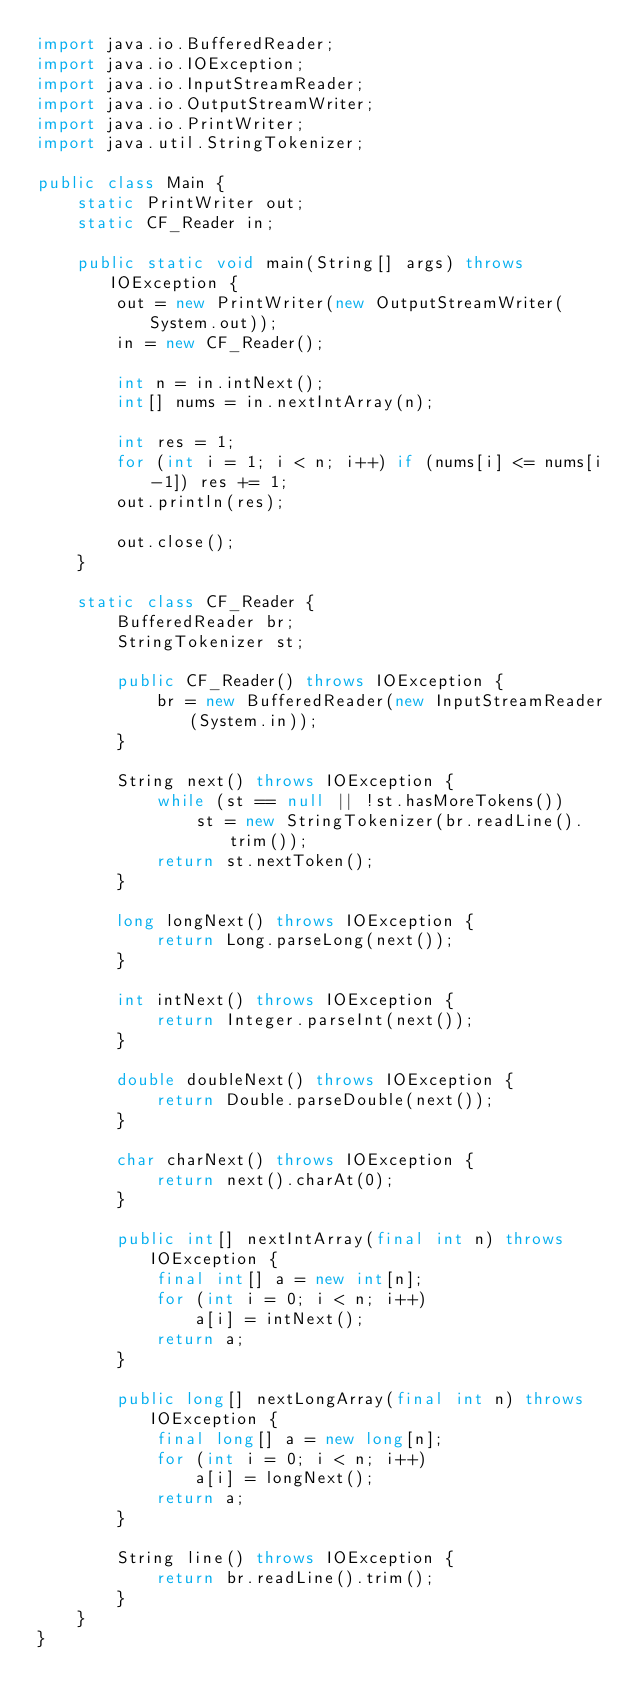<code> <loc_0><loc_0><loc_500><loc_500><_Java_>import java.io.BufferedReader;
import java.io.IOException;
import java.io.InputStreamReader;
import java.io.OutputStreamWriter;
import java.io.PrintWriter;
import java.util.StringTokenizer;

public class Main {
    static PrintWriter out;
    static CF_Reader in;

    public static void main(String[] args) throws IOException {
        out = new PrintWriter(new OutputStreamWriter(System.out));
        in = new CF_Reader();

        int n = in.intNext();
        int[] nums = in.nextIntArray(n);

        int res = 1;
        for (int i = 1; i < n; i++) if (nums[i] <= nums[i-1]) res += 1;
        out.println(res);

        out.close();
    }

    static class CF_Reader {
        BufferedReader br;
        StringTokenizer st;

        public CF_Reader() throws IOException {
            br = new BufferedReader(new InputStreamReader(System.in));
        }

        String next() throws IOException {
            while (st == null || !st.hasMoreTokens())
                st = new StringTokenizer(br.readLine().trim());
            return st.nextToken();
        }

        long longNext() throws IOException {
            return Long.parseLong(next());
        }

        int intNext() throws IOException {
            return Integer.parseInt(next());
        }

        double doubleNext() throws IOException {
            return Double.parseDouble(next());
        }

        char charNext() throws IOException {
            return next().charAt(0);
        }

        public int[] nextIntArray(final int n) throws IOException {
            final int[] a = new int[n];
            for (int i = 0; i < n; i++)
                a[i] = intNext();
            return a;
        }

        public long[] nextLongArray(final int n) throws IOException {
            final long[] a = new long[n];
            for (int i = 0; i < n; i++)
                a[i] = longNext();
            return a;
        }

        String line() throws IOException {
            return br.readLine().trim();
        }
    }
}
</code> 